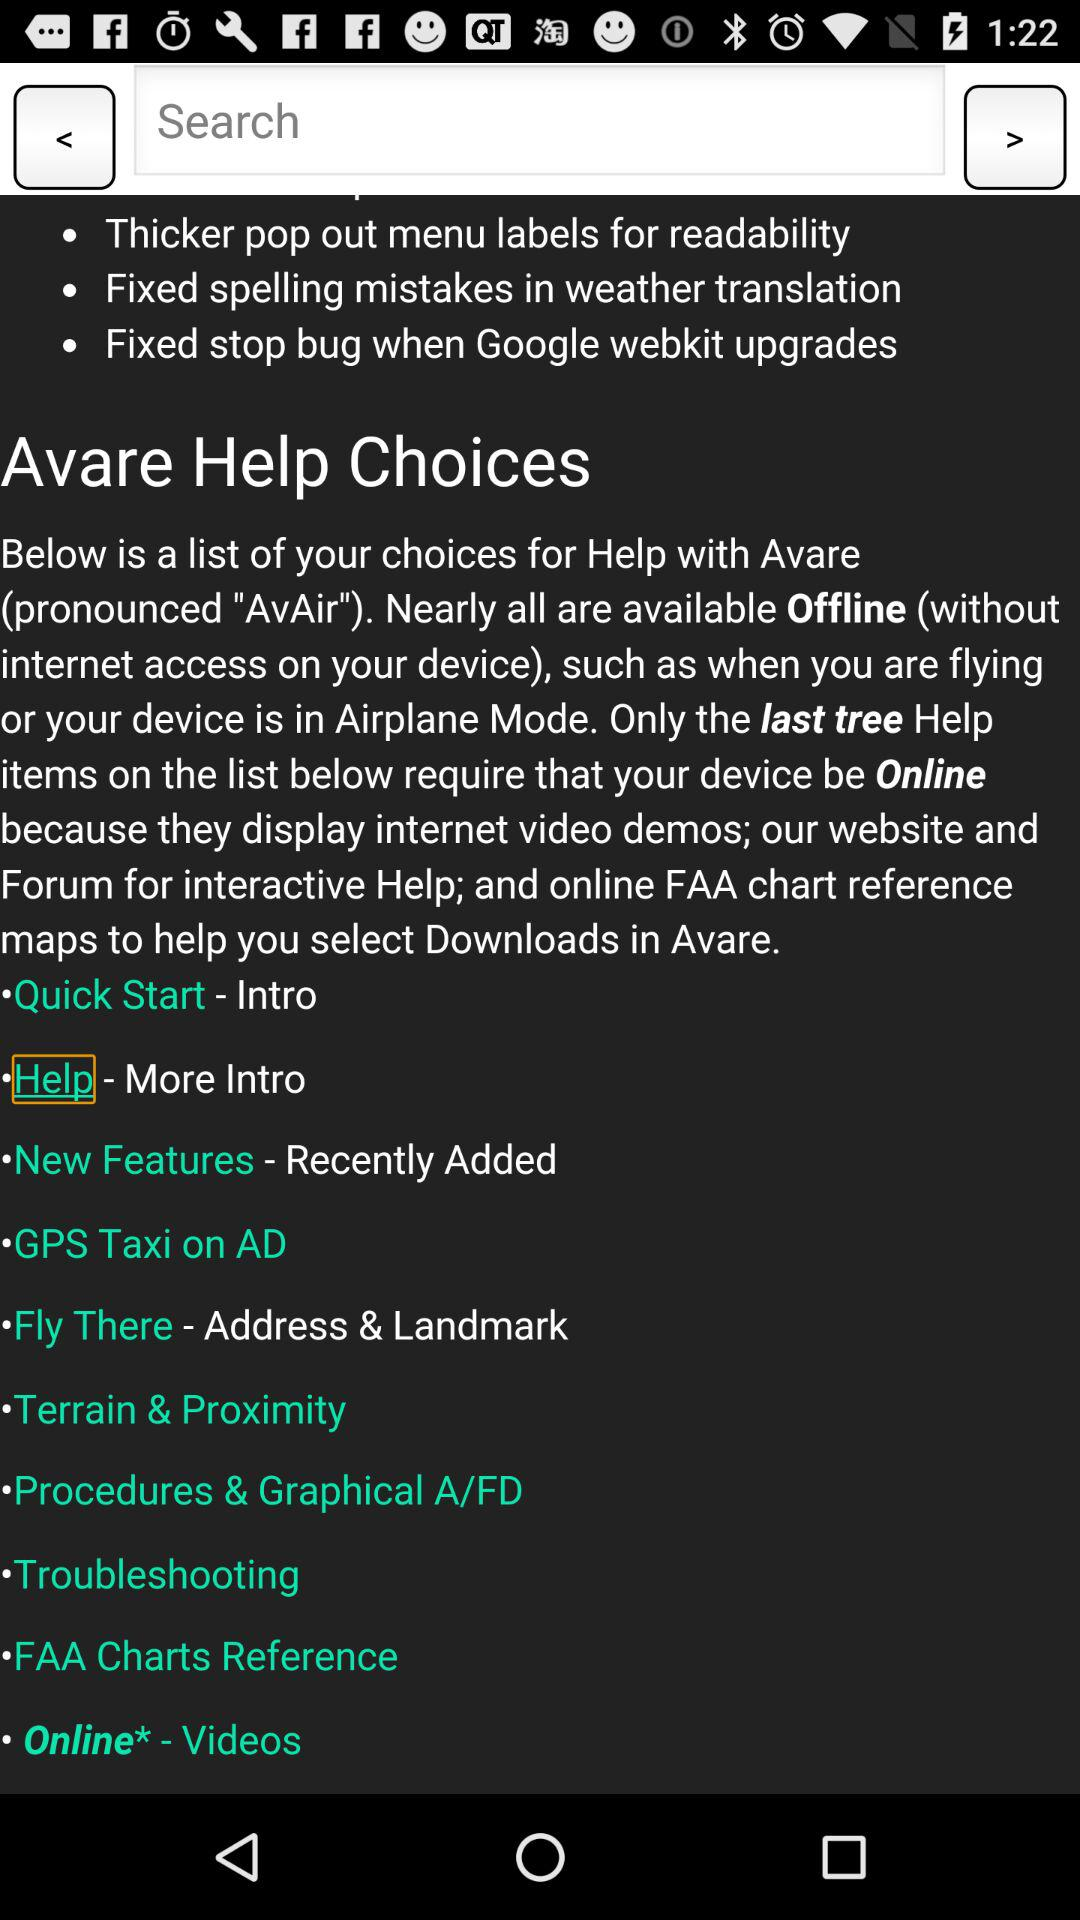How many help topics require an internet connection?
Answer the question using a single word or phrase. 3 